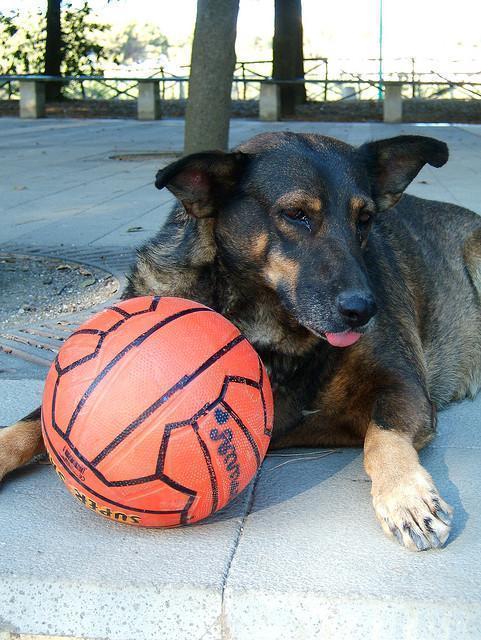What kind of ball is the dog sitting next to on the concrete?
Indicate the correct choice and explain in the format: 'Answer: answer
Rationale: rationale.'
Options: Soccer, tennis ball, basketball, baseball. Answer: basketball.
Rationale: He is sitting next to a orange basketball. 